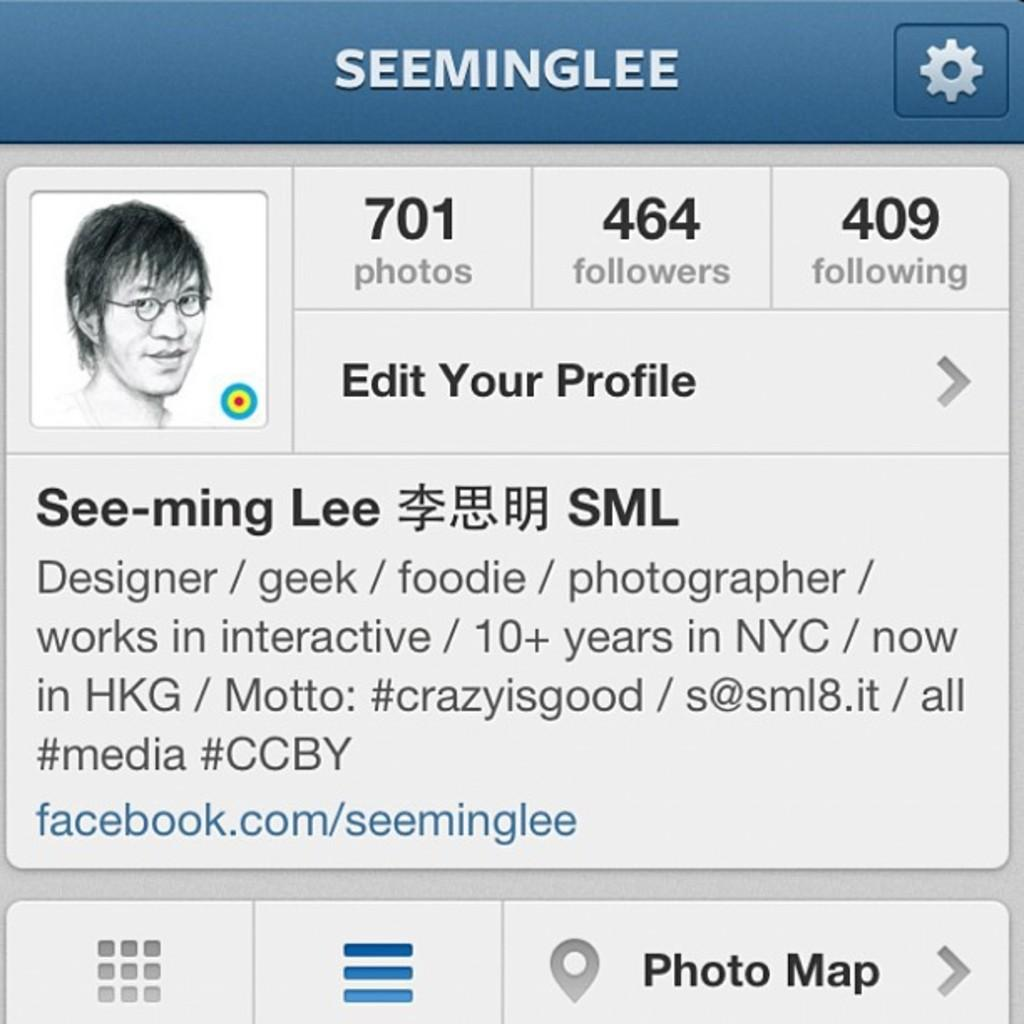What type of image is shown in the screenshot? The image is a screenshot. What can be seen within the screenshot? There is an image of a person and text in the screenshot. Are there any additional elements in the screenshot? Yes, there are icons at the bottom side of the screenshot. How many flags can be seen in the image? There are no flags present in the image. What type of squirrel is interacting with the person in the image? There is no squirrel present in the image; it only features a person and text. 